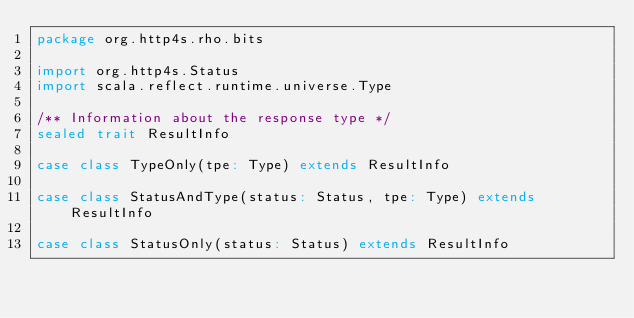<code> <loc_0><loc_0><loc_500><loc_500><_Scala_>package org.http4s.rho.bits

import org.http4s.Status
import scala.reflect.runtime.universe.Type

/** Information about the response type */
sealed trait ResultInfo

case class TypeOnly(tpe: Type) extends ResultInfo

case class StatusAndType(status: Status, tpe: Type) extends ResultInfo

case class StatusOnly(status: Status) extends ResultInfo
</code> 